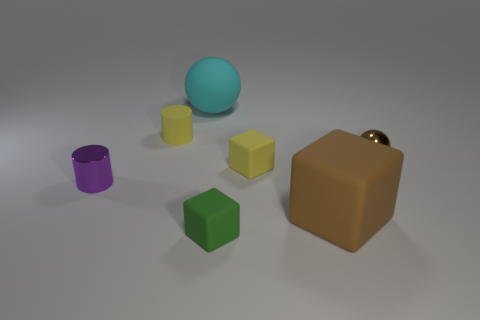Add 1 yellow rubber cylinders. How many objects exist? 8 Subtract all spheres. How many objects are left? 5 Add 6 small yellow objects. How many small yellow objects are left? 8 Add 3 cyan cubes. How many cyan cubes exist? 3 Subtract 1 brown cubes. How many objects are left? 6 Subtract all blocks. Subtract all large brown rubber cubes. How many objects are left? 3 